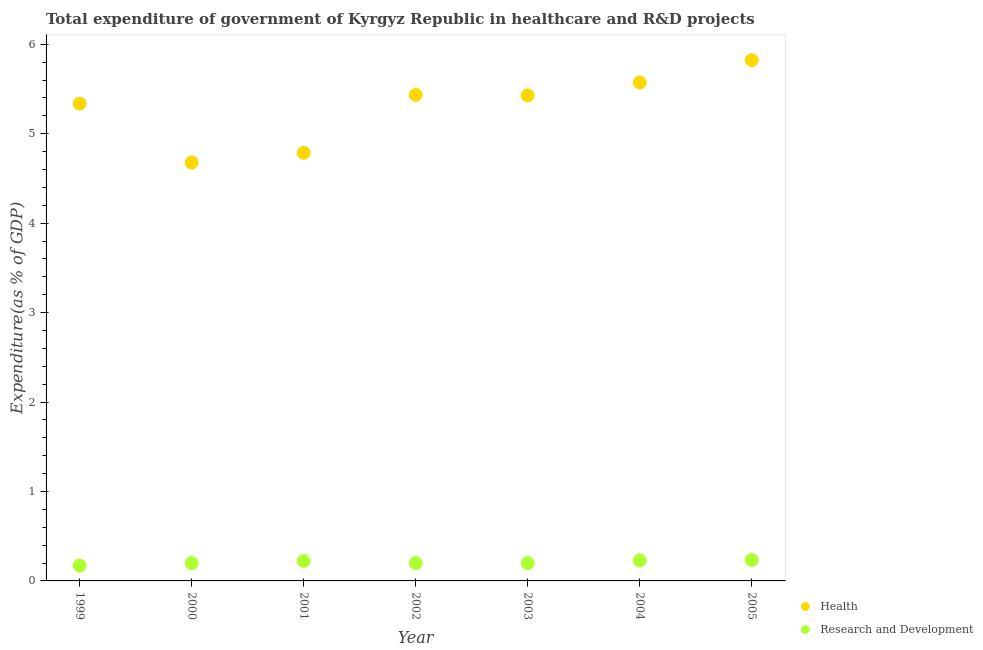How many different coloured dotlines are there?
Your answer should be compact. 2. Is the number of dotlines equal to the number of legend labels?
Offer a very short reply. Yes. What is the expenditure in r&d in 2000?
Your answer should be compact. 0.2. Across all years, what is the maximum expenditure in healthcare?
Keep it short and to the point. 5.82. Across all years, what is the minimum expenditure in r&d?
Ensure brevity in your answer.  0.17. In which year was the expenditure in healthcare minimum?
Ensure brevity in your answer.  2000. What is the total expenditure in r&d in the graph?
Give a very brief answer. 1.45. What is the difference between the expenditure in healthcare in 2000 and that in 2003?
Give a very brief answer. -0.75. What is the difference between the expenditure in healthcare in 2005 and the expenditure in r&d in 2004?
Provide a short and direct response. 5.59. What is the average expenditure in healthcare per year?
Give a very brief answer. 5.29. In the year 1999, what is the difference between the expenditure in healthcare and expenditure in r&d?
Your response must be concise. 5.16. What is the ratio of the expenditure in healthcare in 2001 to that in 2003?
Your answer should be compact. 0.88. Is the expenditure in r&d in 2001 less than that in 2003?
Offer a terse response. No. Is the difference between the expenditure in r&d in 1999 and 2000 greater than the difference between the expenditure in healthcare in 1999 and 2000?
Keep it short and to the point. No. What is the difference between the highest and the second highest expenditure in healthcare?
Provide a short and direct response. 0.25. What is the difference between the highest and the lowest expenditure in healthcare?
Offer a terse response. 1.15. In how many years, is the expenditure in r&d greater than the average expenditure in r&d taken over all years?
Make the answer very short. 3. Is the sum of the expenditure in healthcare in 2001 and 2005 greater than the maximum expenditure in r&d across all years?
Your answer should be very brief. Yes. Is the expenditure in healthcare strictly less than the expenditure in r&d over the years?
Your response must be concise. No. How many dotlines are there?
Offer a very short reply. 2. Does the graph contain any zero values?
Provide a succinct answer. No. Where does the legend appear in the graph?
Your response must be concise. Bottom right. How many legend labels are there?
Your answer should be very brief. 2. How are the legend labels stacked?
Provide a succinct answer. Vertical. What is the title of the graph?
Give a very brief answer. Total expenditure of government of Kyrgyz Republic in healthcare and R&D projects. Does "Education" appear as one of the legend labels in the graph?
Your answer should be compact. No. What is the label or title of the Y-axis?
Provide a short and direct response. Expenditure(as % of GDP). What is the Expenditure(as % of GDP) of Health in 1999?
Ensure brevity in your answer.  5.34. What is the Expenditure(as % of GDP) in Research and Development in 1999?
Offer a very short reply. 0.17. What is the Expenditure(as % of GDP) of Health in 2000?
Make the answer very short. 4.68. What is the Expenditure(as % of GDP) in Research and Development in 2000?
Keep it short and to the point. 0.2. What is the Expenditure(as % of GDP) in Health in 2001?
Ensure brevity in your answer.  4.79. What is the Expenditure(as % of GDP) in Research and Development in 2001?
Your response must be concise. 0.22. What is the Expenditure(as % of GDP) of Health in 2002?
Your answer should be very brief. 5.43. What is the Expenditure(as % of GDP) in Research and Development in 2002?
Offer a very short reply. 0.2. What is the Expenditure(as % of GDP) of Health in 2003?
Ensure brevity in your answer.  5.43. What is the Expenditure(as % of GDP) of Research and Development in 2003?
Your answer should be compact. 0.2. What is the Expenditure(as % of GDP) of Health in 2004?
Offer a terse response. 5.57. What is the Expenditure(as % of GDP) in Research and Development in 2004?
Offer a terse response. 0.23. What is the Expenditure(as % of GDP) of Health in 2005?
Offer a very short reply. 5.82. What is the Expenditure(as % of GDP) in Research and Development in 2005?
Ensure brevity in your answer.  0.23. Across all years, what is the maximum Expenditure(as % of GDP) in Health?
Your answer should be very brief. 5.82. Across all years, what is the maximum Expenditure(as % of GDP) in Research and Development?
Your answer should be compact. 0.23. Across all years, what is the minimum Expenditure(as % of GDP) of Health?
Offer a terse response. 4.68. Across all years, what is the minimum Expenditure(as % of GDP) of Research and Development?
Your answer should be very brief. 0.17. What is the total Expenditure(as % of GDP) in Health in the graph?
Your answer should be very brief. 37.06. What is the total Expenditure(as % of GDP) in Research and Development in the graph?
Offer a terse response. 1.46. What is the difference between the Expenditure(as % of GDP) in Health in 1999 and that in 2000?
Give a very brief answer. 0.66. What is the difference between the Expenditure(as % of GDP) in Research and Development in 1999 and that in 2000?
Provide a succinct answer. -0.03. What is the difference between the Expenditure(as % of GDP) in Health in 1999 and that in 2001?
Provide a short and direct response. 0.55. What is the difference between the Expenditure(as % of GDP) in Research and Development in 1999 and that in 2001?
Provide a short and direct response. -0.05. What is the difference between the Expenditure(as % of GDP) of Health in 1999 and that in 2002?
Ensure brevity in your answer.  -0.1. What is the difference between the Expenditure(as % of GDP) of Research and Development in 1999 and that in 2002?
Offer a terse response. -0.03. What is the difference between the Expenditure(as % of GDP) of Health in 1999 and that in 2003?
Offer a terse response. -0.09. What is the difference between the Expenditure(as % of GDP) in Research and Development in 1999 and that in 2003?
Offer a very short reply. -0.03. What is the difference between the Expenditure(as % of GDP) in Health in 1999 and that in 2004?
Provide a succinct answer. -0.24. What is the difference between the Expenditure(as % of GDP) of Research and Development in 1999 and that in 2004?
Give a very brief answer. -0.06. What is the difference between the Expenditure(as % of GDP) in Health in 1999 and that in 2005?
Your answer should be very brief. -0.49. What is the difference between the Expenditure(as % of GDP) in Research and Development in 1999 and that in 2005?
Provide a short and direct response. -0.06. What is the difference between the Expenditure(as % of GDP) in Health in 2000 and that in 2001?
Give a very brief answer. -0.11. What is the difference between the Expenditure(as % of GDP) in Research and Development in 2000 and that in 2001?
Your answer should be compact. -0.02. What is the difference between the Expenditure(as % of GDP) of Health in 2000 and that in 2002?
Provide a succinct answer. -0.76. What is the difference between the Expenditure(as % of GDP) of Research and Development in 2000 and that in 2002?
Provide a short and direct response. -0. What is the difference between the Expenditure(as % of GDP) of Health in 2000 and that in 2003?
Your response must be concise. -0.75. What is the difference between the Expenditure(as % of GDP) of Research and Development in 2000 and that in 2003?
Ensure brevity in your answer.  -0. What is the difference between the Expenditure(as % of GDP) in Health in 2000 and that in 2004?
Offer a terse response. -0.9. What is the difference between the Expenditure(as % of GDP) of Research and Development in 2000 and that in 2004?
Your answer should be very brief. -0.03. What is the difference between the Expenditure(as % of GDP) in Health in 2000 and that in 2005?
Offer a terse response. -1.15. What is the difference between the Expenditure(as % of GDP) in Research and Development in 2000 and that in 2005?
Offer a terse response. -0.04. What is the difference between the Expenditure(as % of GDP) in Health in 2001 and that in 2002?
Give a very brief answer. -0.65. What is the difference between the Expenditure(as % of GDP) of Research and Development in 2001 and that in 2002?
Your answer should be very brief. 0.02. What is the difference between the Expenditure(as % of GDP) in Health in 2001 and that in 2003?
Make the answer very short. -0.64. What is the difference between the Expenditure(as % of GDP) in Research and Development in 2001 and that in 2003?
Provide a short and direct response. 0.02. What is the difference between the Expenditure(as % of GDP) in Health in 2001 and that in 2004?
Your answer should be compact. -0.79. What is the difference between the Expenditure(as % of GDP) of Research and Development in 2001 and that in 2004?
Offer a terse response. -0.01. What is the difference between the Expenditure(as % of GDP) in Health in 2001 and that in 2005?
Your response must be concise. -1.04. What is the difference between the Expenditure(as % of GDP) of Research and Development in 2001 and that in 2005?
Ensure brevity in your answer.  -0.01. What is the difference between the Expenditure(as % of GDP) of Health in 2002 and that in 2003?
Offer a terse response. 0.01. What is the difference between the Expenditure(as % of GDP) of Research and Development in 2002 and that in 2003?
Give a very brief answer. 0. What is the difference between the Expenditure(as % of GDP) of Health in 2002 and that in 2004?
Provide a short and direct response. -0.14. What is the difference between the Expenditure(as % of GDP) of Research and Development in 2002 and that in 2004?
Keep it short and to the point. -0.03. What is the difference between the Expenditure(as % of GDP) of Health in 2002 and that in 2005?
Make the answer very short. -0.39. What is the difference between the Expenditure(as % of GDP) of Research and Development in 2002 and that in 2005?
Your answer should be very brief. -0.04. What is the difference between the Expenditure(as % of GDP) of Health in 2003 and that in 2004?
Provide a short and direct response. -0.14. What is the difference between the Expenditure(as % of GDP) in Research and Development in 2003 and that in 2004?
Your answer should be compact. -0.03. What is the difference between the Expenditure(as % of GDP) in Health in 2003 and that in 2005?
Offer a very short reply. -0.39. What is the difference between the Expenditure(as % of GDP) in Research and Development in 2003 and that in 2005?
Keep it short and to the point. -0.04. What is the difference between the Expenditure(as % of GDP) in Health in 2004 and that in 2005?
Provide a succinct answer. -0.25. What is the difference between the Expenditure(as % of GDP) in Research and Development in 2004 and that in 2005?
Make the answer very short. -0. What is the difference between the Expenditure(as % of GDP) of Health in 1999 and the Expenditure(as % of GDP) of Research and Development in 2000?
Your response must be concise. 5.14. What is the difference between the Expenditure(as % of GDP) of Health in 1999 and the Expenditure(as % of GDP) of Research and Development in 2001?
Your answer should be compact. 5.11. What is the difference between the Expenditure(as % of GDP) in Health in 1999 and the Expenditure(as % of GDP) in Research and Development in 2002?
Provide a succinct answer. 5.14. What is the difference between the Expenditure(as % of GDP) in Health in 1999 and the Expenditure(as % of GDP) in Research and Development in 2003?
Offer a terse response. 5.14. What is the difference between the Expenditure(as % of GDP) of Health in 1999 and the Expenditure(as % of GDP) of Research and Development in 2004?
Give a very brief answer. 5.11. What is the difference between the Expenditure(as % of GDP) of Health in 1999 and the Expenditure(as % of GDP) of Research and Development in 2005?
Your answer should be very brief. 5.1. What is the difference between the Expenditure(as % of GDP) of Health in 2000 and the Expenditure(as % of GDP) of Research and Development in 2001?
Your answer should be compact. 4.45. What is the difference between the Expenditure(as % of GDP) in Health in 2000 and the Expenditure(as % of GDP) in Research and Development in 2002?
Offer a terse response. 4.48. What is the difference between the Expenditure(as % of GDP) in Health in 2000 and the Expenditure(as % of GDP) in Research and Development in 2003?
Provide a short and direct response. 4.48. What is the difference between the Expenditure(as % of GDP) in Health in 2000 and the Expenditure(as % of GDP) in Research and Development in 2004?
Offer a very short reply. 4.45. What is the difference between the Expenditure(as % of GDP) in Health in 2000 and the Expenditure(as % of GDP) in Research and Development in 2005?
Offer a terse response. 4.44. What is the difference between the Expenditure(as % of GDP) in Health in 2001 and the Expenditure(as % of GDP) in Research and Development in 2002?
Provide a succinct answer. 4.59. What is the difference between the Expenditure(as % of GDP) of Health in 2001 and the Expenditure(as % of GDP) of Research and Development in 2003?
Make the answer very short. 4.59. What is the difference between the Expenditure(as % of GDP) of Health in 2001 and the Expenditure(as % of GDP) of Research and Development in 2004?
Your answer should be very brief. 4.56. What is the difference between the Expenditure(as % of GDP) of Health in 2001 and the Expenditure(as % of GDP) of Research and Development in 2005?
Your answer should be very brief. 4.55. What is the difference between the Expenditure(as % of GDP) of Health in 2002 and the Expenditure(as % of GDP) of Research and Development in 2003?
Make the answer very short. 5.24. What is the difference between the Expenditure(as % of GDP) of Health in 2002 and the Expenditure(as % of GDP) of Research and Development in 2004?
Your answer should be compact. 5.2. What is the difference between the Expenditure(as % of GDP) in Health in 2003 and the Expenditure(as % of GDP) in Research and Development in 2004?
Your answer should be compact. 5.2. What is the difference between the Expenditure(as % of GDP) of Health in 2003 and the Expenditure(as % of GDP) of Research and Development in 2005?
Keep it short and to the point. 5.19. What is the difference between the Expenditure(as % of GDP) of Health in 2004 and the Expenditure(as % of GDP) of Research and Development in 2005?
Offer a terse response. 5.34. What is the average Expenditure(as % of GDP) in Health per year?
Your response must be concise. 5.29. What is the average Expenditure(as % of GDP) in Research and Development per year?
Make the answer very short. 0.21. In the year 1999, what is the difference between the Expenditure(as % of GDP) of Health and Expenditure(as % of GDP) of Research and Development?
Provide a short and direct response. 5.16. In the year 2000, what is the difference between the Expenditure(as % of GDP) of Health and Expenditure(as % of GDP) of Research and Development?
Ensure brevity in your answer.  4.48. In the year 2001, what is the difference between the Expenditure(as % of GDP) of Health and Expenditure(as % of GDP) of Research and Development?
Ensure brevity in your answer.  4.56. In the year 2002, what is the difference between the Expenditure(as % of GDP) of Health and Expenditure(as % of GDP) of Research and Development?
Make the answer very short. 5.23. In the year 2003, what is the difference between the Expenditure(as % of GDP) in Health and Expenditure(as % of GDP) in Research and Development?
Ensure brevity in your answer.  5.23. In the year 2004, what is the difference between the Expenditure(as % of GDP) in Health and Expenditure(as % of GDP) in Research and Development?
Provide a succinct answer. 5.34. In the year 2005, what is the difference between the Expenditure(as % of GDP) in Health and Expenditure(as % of GDP) in Research and Development?
Provide a short and direct response. 5.59. What is the ratio of the Expenditure(as % of GDP) in Health in 1999 to that in 2000?
Give a very brief answer. 1.14. What is the ratio of the Expenditure(as % of GDP) of Research and Development in 1999 to that in 2000?
Make the answer very short. 0.87. What is the ratio of the Expenditure(as % of GDP) of Health in 1999 to that in 2001?
Provide a short and direct response. 1.12. What is the ratio of the Expenditure(as % of GDP) of Research and Development in 1999 to that in 2001?
Your response must be concise. 0.77. What is the ratio of the Expenditure(as % of GDP) of Health in 1999 to that in 2002?
Keep it short and to the point. 0.98. What is the ratio of the Expenditure(as % of GDP) of Research and Development in 1999 to that in 2002?
Provide a short and direct response. 0.86. What is the ratio of the Expenditure(as % of GDP) in Health in 1999 to that in 2003?
Provide a succinct answer. 0.98. What is the ratio of the Expenditure(as % of GDP) in Research and Development in 1999 to that in 2003?
Give a very brief answer. 0.87. What is the ratio of the Expenditure(as % of GDP) of Health in 1999 to that in 2004?
Give a very brief answer. 0.96. What is the ratio of the Expenditure(as % of GDP) in Research and Development in 1999 to that in 2004?
Offer a terse response. 0.75. What is the ratio of the Expenditure(as % of GDP) of Health in 1999 to that in 2005?
Provide a short and direct response. 0.92. What is the ratio of the Expenditure(as % of GDP) in Research and Development in 1999 to that in 2005?
Your response must be concise. 0.73. What is the ratio of the Expenditure(as % of GDP) in Health in 2000 to that in 2001?
Your answer should be compact. 0.98. What is the ratio of the Expenditure(as % of GDP) of Research and Development in 2000 to that in 2001?
Provide a short and direct response. 0.89. What is the ratio of the Expenditure(as % of GDP) of Health in 2000 to that in 2002?
Your answer should be very brief. 0.86. What is the ratio of the Expenditure(as % of GDP) of Research and Development in 2000 to that in 2002?
Your response must be concise. 0.99. What is the ratio of the Expenditure(as % of GDP) of Health in 2000 to that in 2003?
Give a very brief answer. 0.86. What is the ratio of the Expenditure(as % of GDP) of Health in 2000 to that in 2004?
Give a very brief answer. 0.84. What is the ratio of the Expenditure(as % of GDP) of Research and Development in 2000 to that in 2004?
Offer a terse response. 0.86. What is the ratio of the Expenditure(as % of GDP) of Health in 2000 to that in 2005?
Your answer should be very brief. 0.8. What is the ratio of the Expenditure(as % of GDP) of Research and Development in 2000 to that in 2005?
Give a very brief answer. 0.85. What is the ratio of the Expenditure(as % of GDP) in Health in 2001 to that in 2002?
Give a very brief answer. 0.88. What is the ratio of the Expenditure(as % of GDP) of Research and Development in 2001 to that in 2002?
Your answer should be very brief. 1.12. What is the ratio of the Expenditure(as % of GDP) of Health in 2001 to that in 2003?
Provide a succinct answer. 0.88. What is the ratio of the Expenditure(as % of GDP) of Research and Development in 2001 to that in 2003?
Offer a terse response. 1.12. What is the ratio of the Expenditure(as % of GDP) in Health in 2001 to that in 2004?
Make the answer very short. 0.86. What is the ratio of the Expenditure(as % of GDP) of Research and Development in 2001 to that in 2004?
Offer a terse response. 0.97. What is the ratio of the Expenditure(as % of GDP) in Health in 2001 to that in 2005?
Provide a succinct answer. 0.82. What is the ratio of the Expenditure(as % of GDP) in Research and Development in 2001 to that in 2005?
Provide a succinct answer. 0.95. What is the ratio of the Expenditure(as % of GDP) of Research and Development in 2002 to that in 2003?
Ensure brevity in your answer.  1. What is the ratio of the Expenditure(as % of GDP) in Health in 2002 to that in 2004?
Provide a succinct answer. 0.98. What is the ratio of the Expenditure(as % of GDP) in Research and Development in 2002 to that in 2004?
Provide a succinct answer. 0.87. What is the ratio of the Expenditure(as % of GDP) of Research and Development in 2002 to that in 2005?
Keep it short and to the point. 0.85. What is the ratio of the Expenditure(as % of GDP) in Health in 2003 to that in 2004?
Provide a succinct answer. 0.97. What is the ratio of the Expenditure(as % of GDP) in Research and Development in 2003 to that in 2004?
Keep it short and to the point. 0.86. What is the ratio of the Expenditure(as % of GDP) in Health in 2003 to that in 2005?
Your response must be concise. 0.93. What is the ratio of the Expenditure(as % of GDP) of Research and Development in 2003 to that in 2005?
Give a very brief answer. 0.85. What is the ratio of the Expenditure(as % of GDP) in Health in 2004 to that in 2005?
Make the answer very short. 0.96. What is the ratio of the Expenditure(as % of GDP) of Research and Development in 2004 to that in 2005?
Make the answer very short. 0.98. What is the difference between the highest and the second highest Expenditure(as % of GDP) in Health?
Your response must be concise. 0.25. What is the difference between the highest and the second highest Expenditure(as % of GDP) of Research and Development?
Make the answer very short. 0. What is the difference between the highest and the lowest Expenditure(as % of GDP) in Health?
Provide a succinct answer. 1.15. What is the difference between the highest and the lowest Expenditure(as % of GDP) in Research and Development?
Your response must be concise. 0.06. 